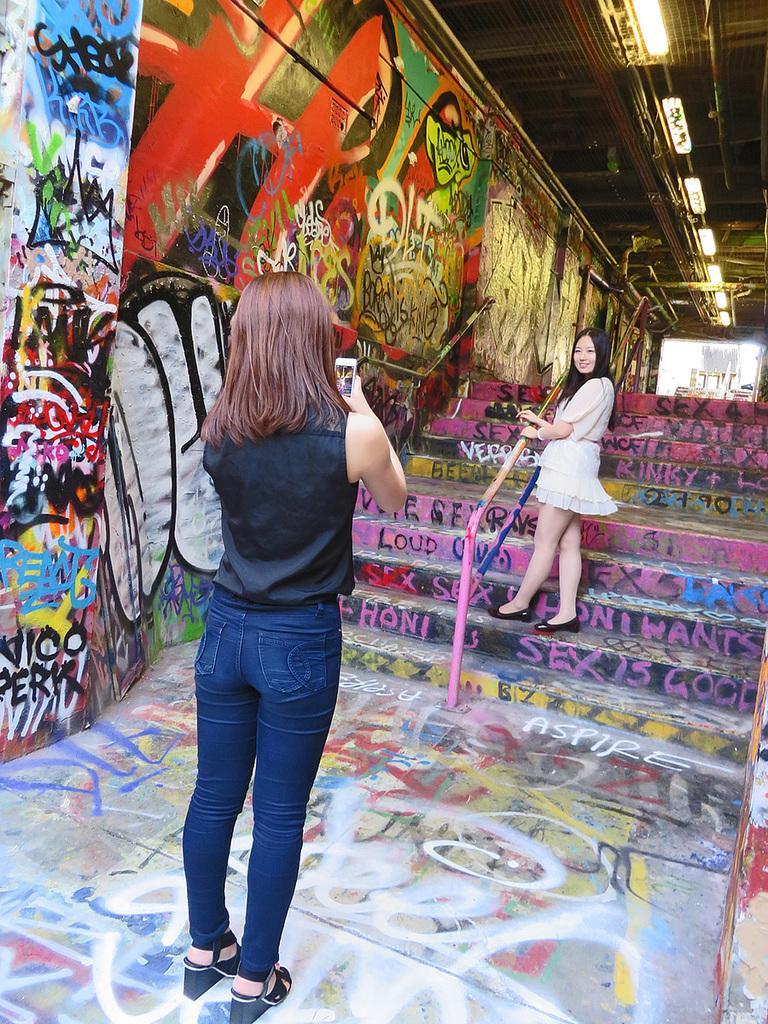How would you summarize this image in a sentence or two? In this image we can see a woman is standing, and holding a mobile in the hand, here a woman is standing on the staircase and smiling, here is the wall, at above here are the lights. 